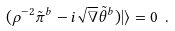Convert formula to latex. <formula><loc_0><loc_0><loc_500><loc_500>( \rho ^ { - 2 } \tilde { \pi } ^ { b } - i \sqrt { \nabla } \tilde { \theta } ^ { b } ) | \rangle = 0 \ .</formula> 